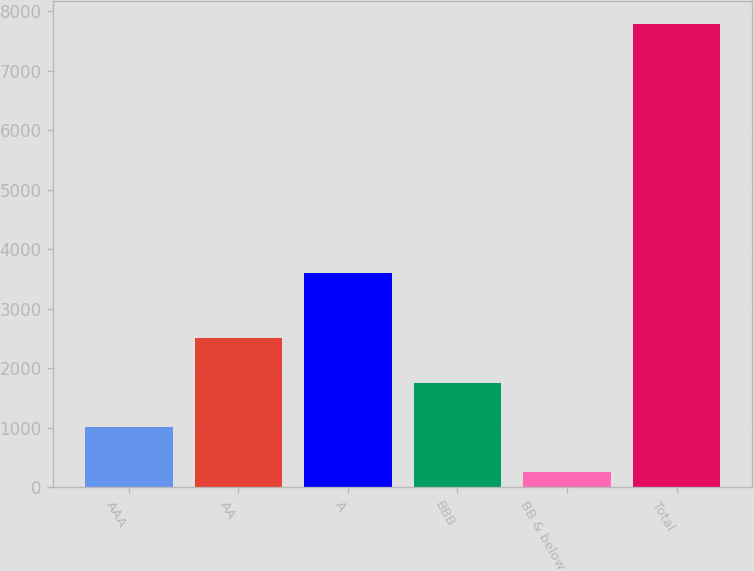<chart> <loc_0><loc_0><loc_500><loc_500><bar_chart><fcel>AAA<fcel>AA<fcel>A<fcel>BBB<fcel>BB & below<fcel>Total<nl><fcel>1005.1<fcel>2509.3<fcel>3599<fcel>1757.2<fcel>253<fcel>7774<nl></chart> 